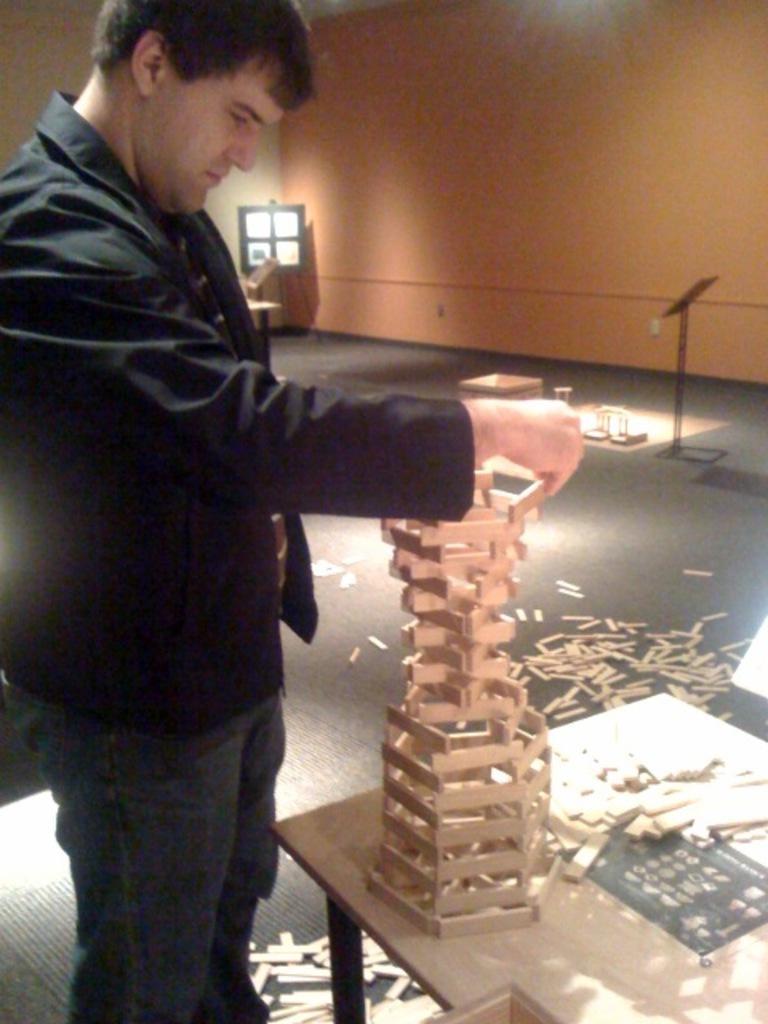Describe this image in one or two sentences. In the picture we can see a man standing near the table on it, we can see a man is doing something with a wooden pieces and he is wearing a black color blazer with tie and to the floor, we can see some wooden pieces on in the background we can see some board to the stand near the wall. 